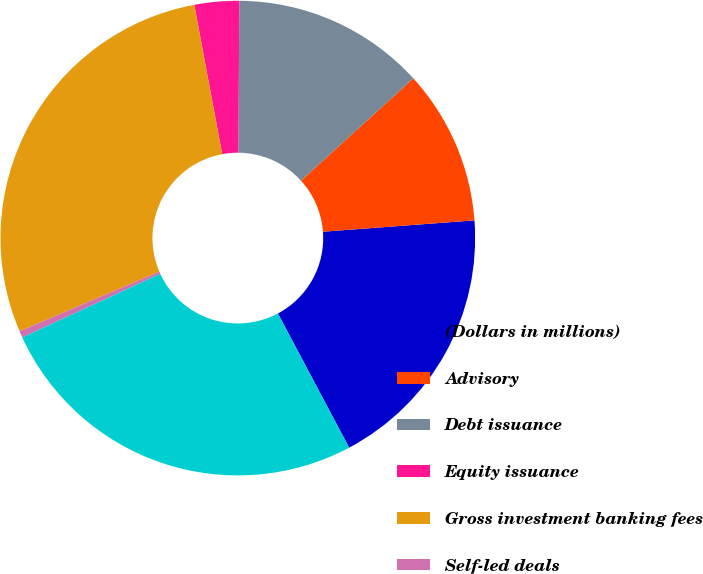Convert chart. <chart><loc_0><loc_0><loc_500><loc_500><pie_chart><fcel>(Dollars in millions)<fcel>Advisory<fcel>Debt issuance<fcel>Equity issuance<fcel>Gross investment banking fees<fcel>Self-led deals<fcel>Total investment banking fees<nl><fcel>18.42%<fcel>10.56%<fcel>13.15%<fcel>3.04%<fcel>28.49%<fcel>0.45%<fcel>25.9%<nl></chart> 